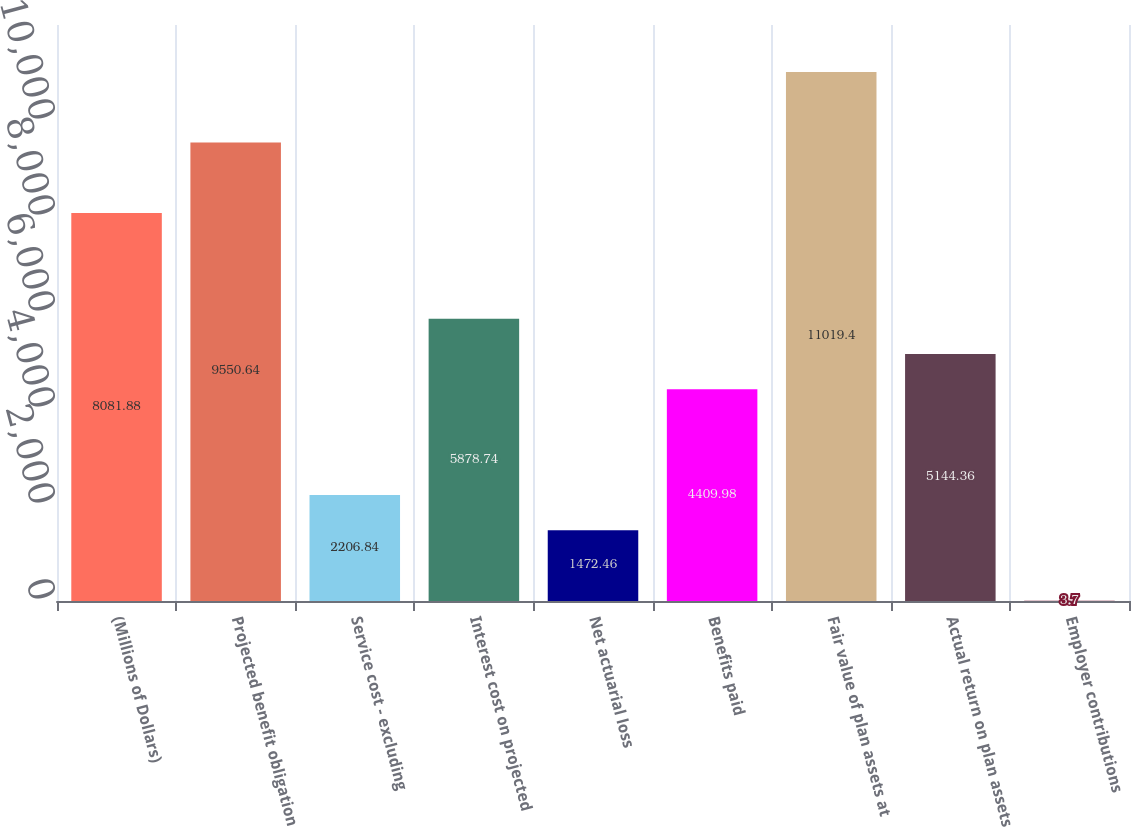Convert chart to OTSL. <chart><loc_0><loc_0><loc_500><loc_500><bar_chart><fcel>(Millions of Dollars)<fcel>Projected benefit obligation<fcel>Service cost - excluding<fcel>Interest cost on projected<fcel>Net actuarial loss<fcel>Benefits paid<fcel>Fair value of plan assets at<fcel>Actual return on plan assets<fcel>Employer contributions<nl><fcel>8081.88<fcel>9550.64<fcel>2206.84<fcel>5878.74<fcel>1472.46<fcel>4409.98<fcel>11019.4<fcel>5144.36<fcel>3.7<nl></chart> 